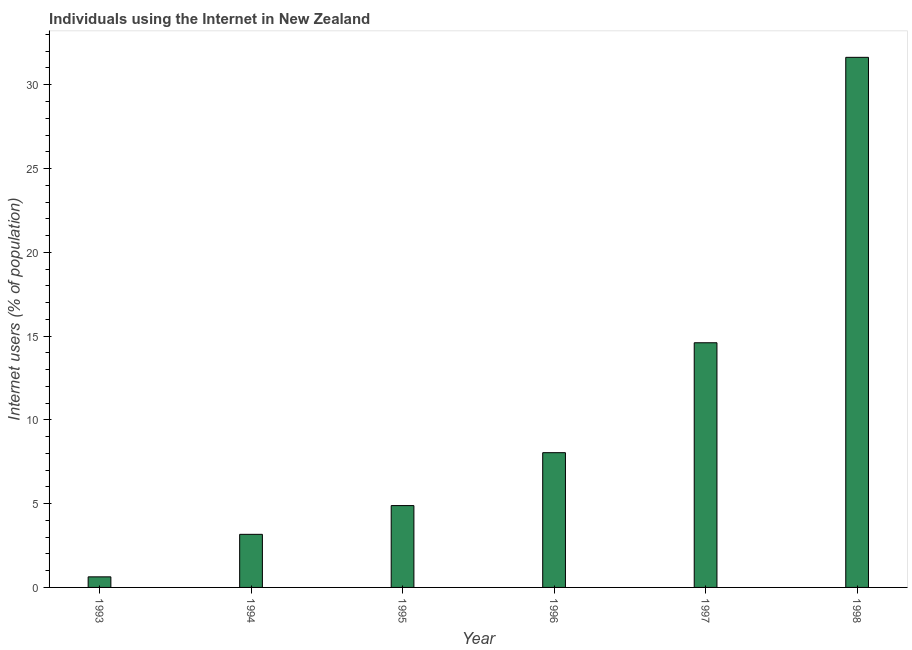What is the title of the graph?
Your response must be concise. Individuals using the Internet in New Zealand. What is the label or title of the X-axis?
Your answer should be compact. Year. What is the label or title of the Y-axis?
Your response must be concise. Internet users (% of population). What is the number of internet users in 1993?
Offer a terse response. 0.63. Across all years, what is the maximum number of internet users?
Offer a terse response. 31.64. Across all years, what is the minimum number of internet users?
Your answer should be very brief. 0.63. In which year was the number of internet users maximum?
Your answer should be very brief. 1998. In which year was the number of internet users minimum?
Your answer should be compact. 1993. What is the sum of the number of internet users?
Your response must be concise. 62.96. What is the difference between the number of internet users in 1996 and 1998?
Make the answer very short. -23.59. What is the average number of internet users per year?
Your response must be concise. 10.49. What is the median number of internet users?
Provide a succinct answer. 6.46. What is the ratio of the number of internet users in 1994 to that in 1995?
Your answer should be compact. 0.65. Is the difference between the number of internet users in 1993 and 1994 greater than the difference between any two years?
Provide a succinct answer. No. What is the difference between the highest and the second highest number of internet users?
Ensure brevity in your answer.  17.04. Is the sum of the number of internet users in 1993 and 1998 greater than the maximum number of internet users across all years?
Ensure brevity in your answer.  Yes. What is the difference between the highest and the lowest number of internet users?
Give a very brief answer. 31.01. In how many years, is the number of internet users greater than the average number of internet users taken over all years?
Keep it short and to the point. 2. How many bars are there?
Provide a succinct answer. 6. Are all the bars in the graph horizontal?
Your answer should be very brief. No. What is the difference between two consecutive major ticks on the Y-axis?
Give a very brief answer. 5. Are the values on the major ticks of Y-axis written in scientific E-notation?
Make the answer very short. No. What is the Internet users (% of population) of 1993?
Provide a succinct answer. 0.63. What is the Internet users (% of population) in 1994?
Your answer should be compact. 3.17. What is the Internet users (% of population) in 1995?
Offer a very short reply. 4.88. What is the Internet users (% of population) of 1996?
Your answer should be very brief. 8.04. What is the Internet users (% of population) in 1997?
Offer a terse response. 14.6. What is the Internet users (% of population) in 1998?
Provide a succinct answer. 31.64. What is the difference between the Internet users (% of population) in 1993 and 1994?
Keep it short and to the point. -2.54. What is the difference between the Internet users (% of population) in 1993 and 1995?
Provide a short and direct response. -4.25. What is the difference between the Internet users (% of population) in 1993 and 1996?
Give a very brief answer. -7.41. What is the difference between the Internet users (% of population) in 1993 and 1997?
Provide a short and direct response. -13.97. What is the difference between the Internet users (% of population) in 1993 and 1998?
Your response must be concise. -31.01. What is the difference between the Internet users (% of population) in 1994 and 1995?
Your answer should be very brief. -1.72. What is the difference between the Internet users (% of population) in 1994 and 1996?
Ensure brevity in your answer.  -4.87. What is the difference between the Internet users (% of population) in 1994 and 1997?
Provide a succinct answer. -11.43. What is the difference between the Internet users (% of population) in 1994 and 1998?
Your answer should be compact. -28.47. What is the difference between the Internet users (% of population) in 1995 and 1996?
Offer a very short reply. -3.16. What is the difference between the Internet users (% of population) in 1995 and 1997?
Your answer should be very brief. -9.72. What is the difference between the Internet users (% of population) in 1995 and 1998?
Your response must be concise. -26.75. What is the difference between the Internet users (% of population) in 1996 and 1997?
Your answer should be compact. -6.56. What is the difference between the Internet users (% of population) in 1996 and 1998?
Make the answer very short. -23.59. What is the difference between the Internet users (% of population) in 1997 and 1998?
Offer a very short reply. -17.03. What is the ratio of the Internet users (% of population) in 1993 to that in 1994?
Provide a succinct answer. 0.2. What is the ratio of the Internet users (% of population) in 1993 to that in 1995?
Offer a very short reply. 0.13. What is the ratio of the Internet users (% of population) in 1993 to that in 1996?
Keep it short and to the point. 0.08. What is the ratio of the Internet users (% of population) in 1993 to that in 1997?
Keep it short and to the point. 0.04. What is the ratio of the Internet users (% of population) in 1993 to that in 1998?
Your answer should be compact. 0.02. What is the ratio of the Internet users (% of population) in 1994 to that in 1995?
Your answer should be compact. 0.65. What is the ratio of the Internet users (% of population) in 1994 to that in 1996?
Provide a succinct answer. 0.39. What is the ratio of the Internet users (% of population) in 1994 to that in 1997?
Your answer should be very brief. 0.22. What is the ratio of the Internet users (% of population) in 1994 to that in 1998?
Provide a short and direct response. 0.1. What is the ratio of the Internet users (% of population) in 1995 to that in 1996?
Your answer should be compact. 0.61. What is the ratio of the Internet users (% of population) in 1995 to that in 1997?
Give a very brief answer. 0.34. What is the ratio of the Internet users (% of population) in 1995 to that in 1998?
Make the answer very short. 0.15. What is the ratio of the Internet users (% of population) in 1996 to that in 1997?
Your response must be concise. 0.55. What is the ratio of the Internet users (% of population) in 1996 to that in 1998?
Your answer should be compact. 0.25. What is the ratio of the Internet users (% of population) in 1997 to that in 1998?
Make the answer very short. 0.46. 